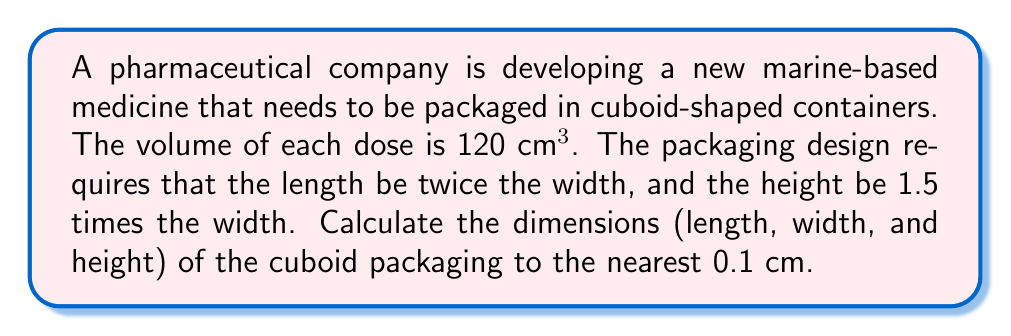Show me your answer to this math problem. Let's approach this step-by-step:

1) Let the width of the cuboid be $w$ cm.
2) Given the conditions:
   - Length = $2w$ cm
   - Height = $1.5w$ cm
   - Width = $w$ cm

3) The volume of a cuboid is given by length × width × height:
   $$ V = l \times w \times h $$

4) Substituting our known values:
   $$ 120 = 2w \times w \times 1.5w $$

5) Simplifying:
   $$ 120 = 3w^3 $$

6) Solving for $w$:
   $$ w^3 = \frac{120}{3} = 40 $$
   $$ w = \sqrt[3]{40} \approx 3.4199 \text{ cm} $$

7) Rounding to the nearest 0.1 cm:
   $$ w \approx 3.4 \text{ cm} $$

8) Now we can calculate the other dimensions:
   - Length = $2w \approx 2 \times 3.4 = 6.8 \text{ cm}$
   - Height = $1.5w \approx 1.5 \times 3.4 = 5.1 \text{ cm}$

9) Let's verify the volume:
   $$ V = 6.8 \times 3.4 \times 5.1 \approx 117.912 \text{ cm}^3 $$
   This is very close to 120 cm³, with the small difference due to rounding.
Answer: The dimensions of the cuboid packaging are approximately:
Length = 6.8 cm
Width = 3.4 cm
Height = 5.1 cm 